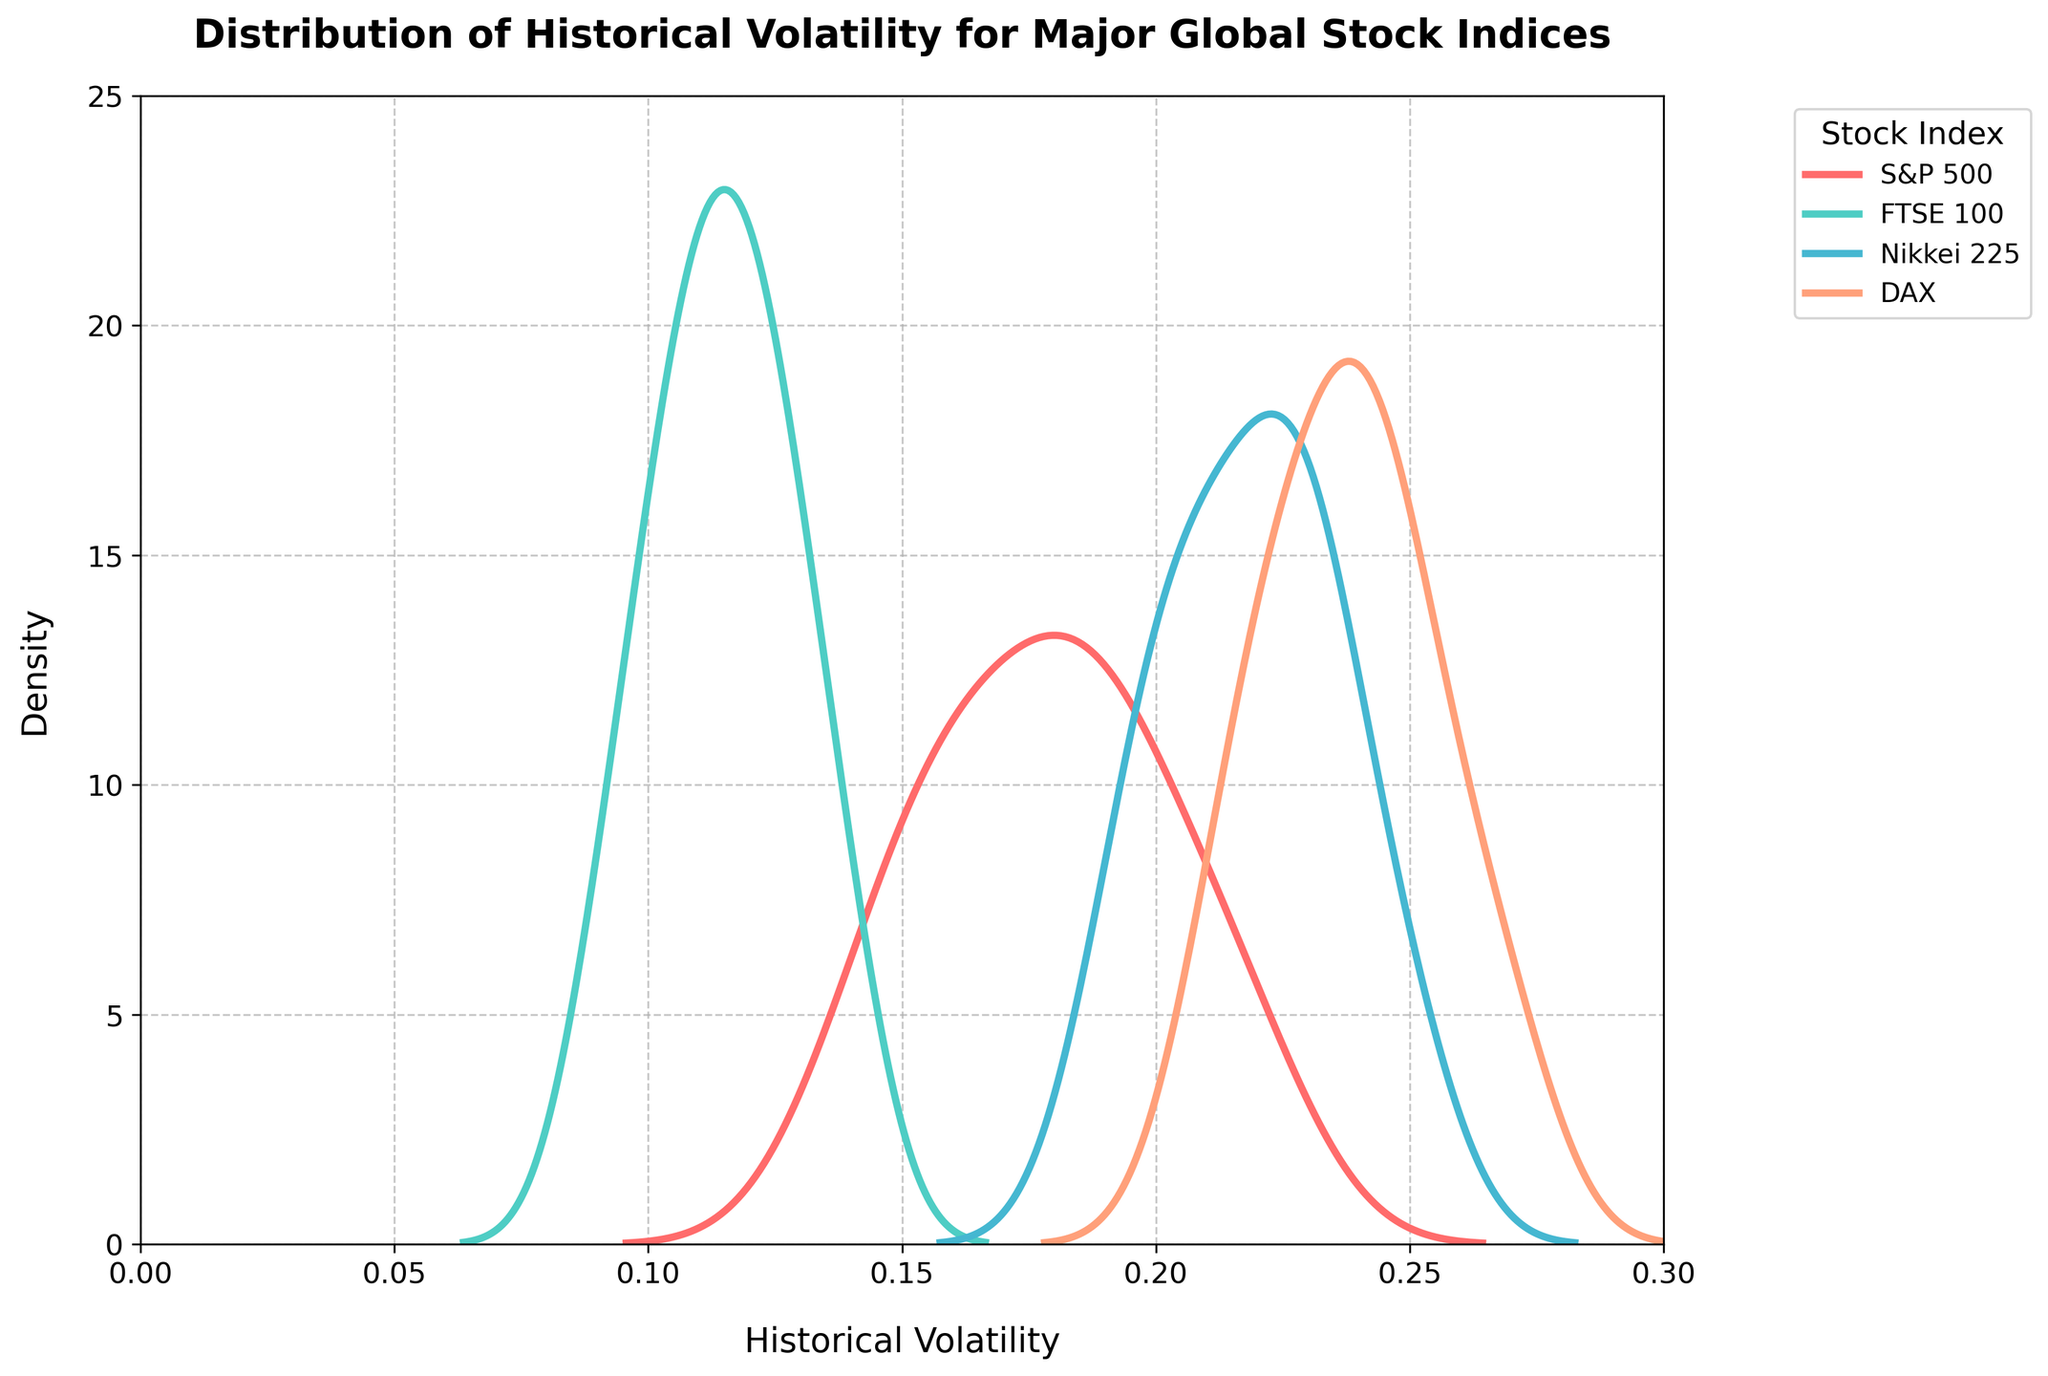what is the title of the figure? The title is located at the top of the figure, typically in bold font for emphasis. The title for this distplot is ‘Distribution of Historical Volatility for Major Global Stock Indices’.
Answer: Distribution of Historical Volatility for Major Global Stock Indices what is the highest density value reached in the distplot? The highest density value can be observed on the y-axis where the KDE lines for each index peak. The highest density value reached in this distplot is approximately 20.
Answer: 20 which stock index shows the broadest distribution of historical volatility? To determine which stock index shows the broadest distribution, we look for the KDE line that spreads out the furthest across the x-axis. The DAX index shows the broadest distribution.
Answer: DAX whose KDE peak is the highest, the S&P 500 or the FTSE 100? Comparing the peaks of the KDE lines, the FTSE 100 has the highest peak when compared to the S&P 500.
Answer: FTSE 100 are there any indices with a volatility density peak above 15? Looking at the KDE peaks, the FTSE 100 and the S&P 500 show density peaks above 15.
Answer: Yes which index shows the most variability in historical volatility? The most variability can be identified by the widest distribution or range of values on the x-axis. The DAX index shows the most variability in historical volatility.
Answer: DAX which stock index has the narrowest distribution of volatility? The narrowest distribution is indicated by the KDE line that is the least spread across the x-axis. The FTSE 100 has the narrowest distribution of volatility.
Answer: FTSE 100 how many major global stock indices are plotted? The number of indices can be identified by the number of different colored KDE lines in the legend. There are four major global stock indices plotted: S&P 500, FTSE 100, Nikkei 225, and DAX.
Answer: 4 do all indices share the same x-axis range? Yes, the x-axis range is set from 0 to 0.3 for all indices in the figure. This keeps the scale consistent across all distributions.
Answer: Yes 